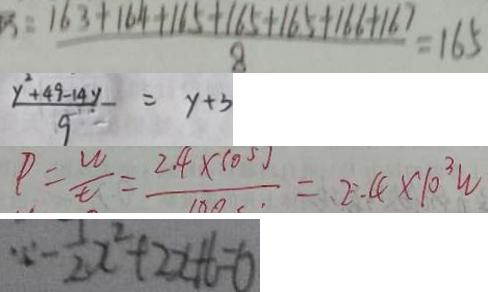Convert formula to latex. <formula><loc_0><loc_0><loc_500><loc_500>: \frac { 1 6 3 + 1 6 4 + 1 6 5 + 1 6 5 + 1 6 5 + 1 6 6 + 1 6 7 } { 8 } = 1 6 5 
 \frac { y ^ { 2 } + 4 9 - 1 4 y } { 9 } - = y + 3 
 P = \frac { w } { t } = \frac { 2 4 \times 1 0 5 j } { 1 8 0 } = 2 . 4 \times 1 0 ^ { 3 } w 
 \because - \frac { 1 } { 2 } x ^ { 2 } + 2 x + 6 = 0</formula> 